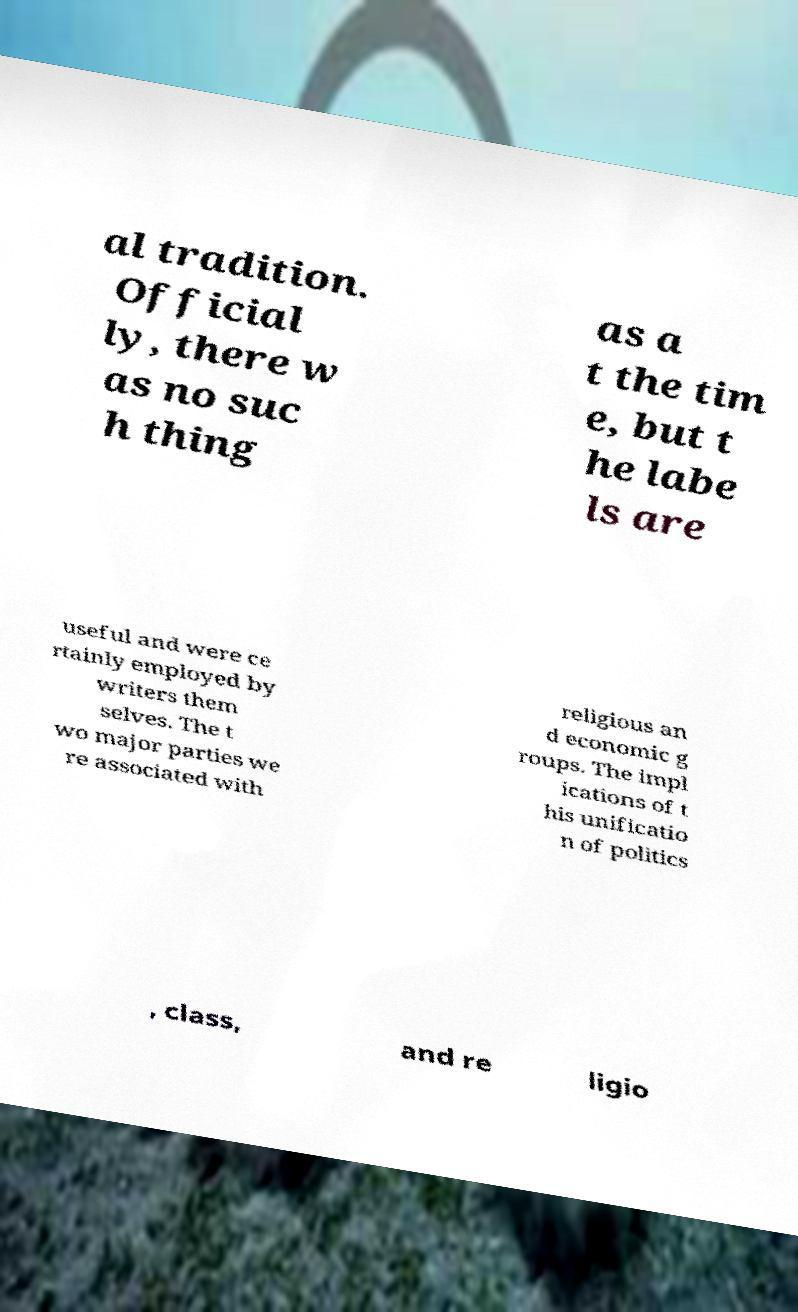Please identify and transcribe the text found in this image. al tradition. Official ly, there w as no suc h thing as a t the tim e, but t he labe ls are useful and were ce rtainly employed by writers them selves. The t wo major parties we re associated with religious an d economic g roups. The impl ications of t his unificatio n of politics , class, and re ligio 